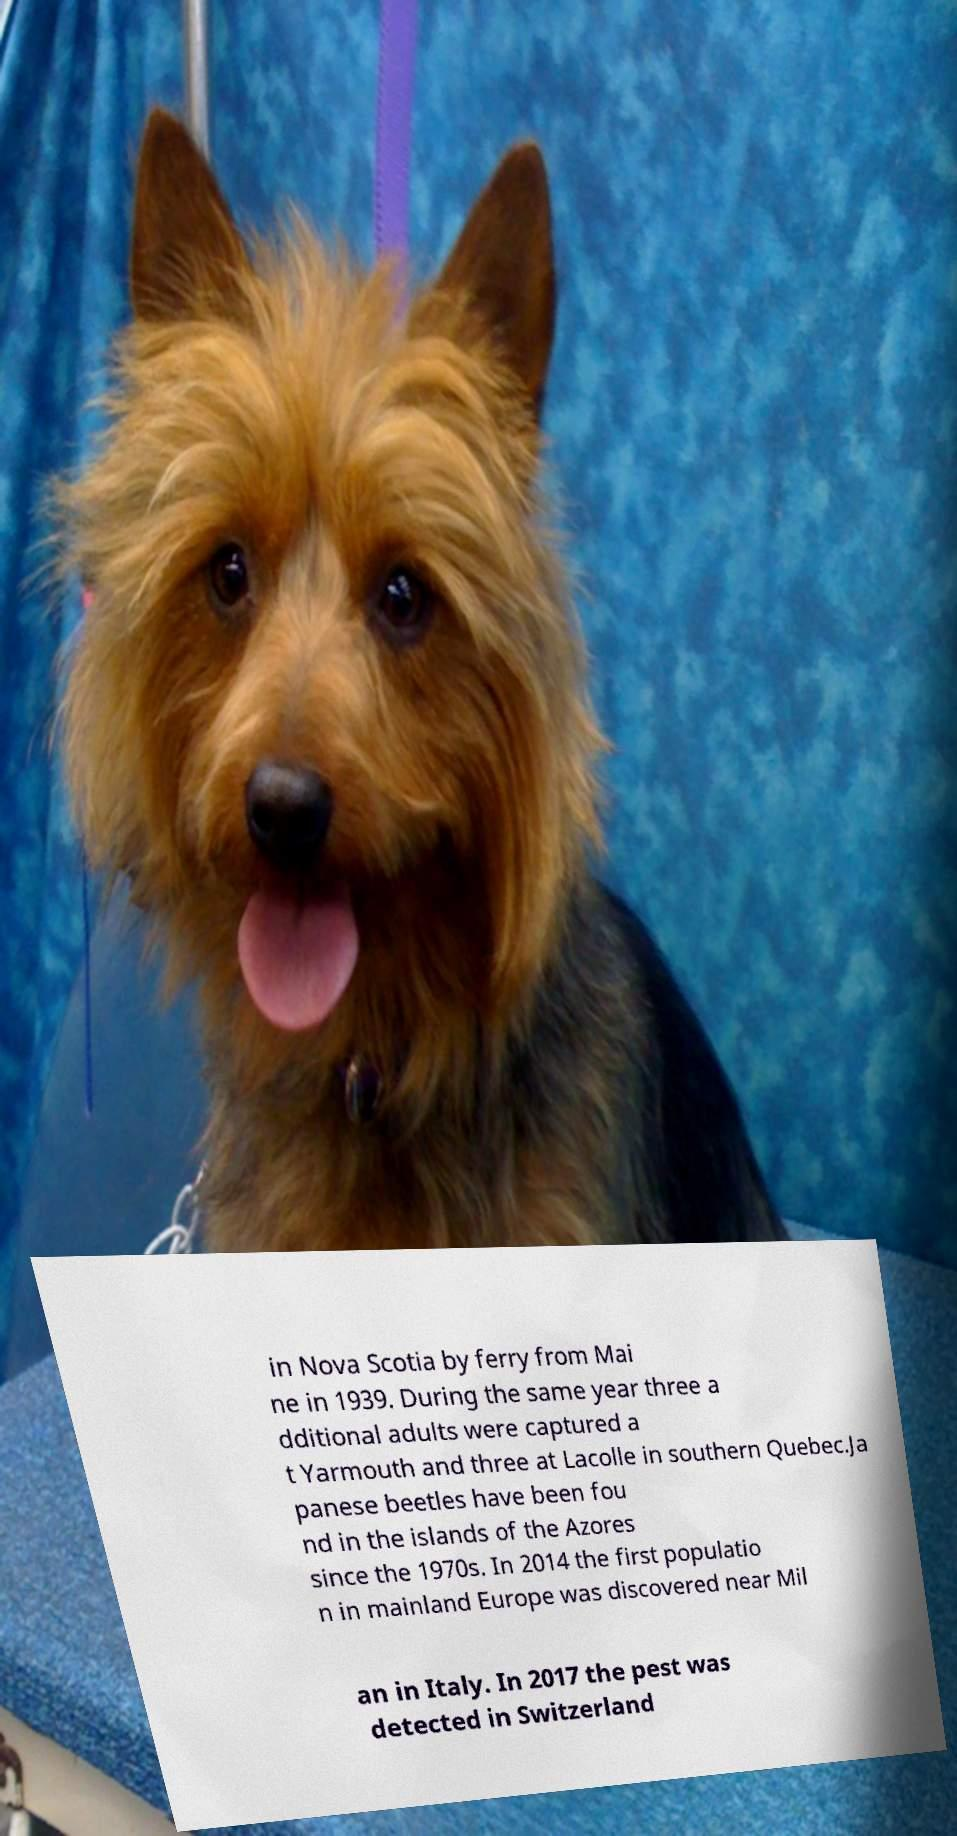Please identify and transcribe the text found in this image. in Nova Scotia by ferry from Mai ne in 1939. During the same year three a dditional adults were captured a t Yarmouth and three at Lacolle in southern Quebec.Ja panese beetles have been fou nd in the islands of the Azores since the 1970s. In 2014 the first populatio n in mainland Europe was discovered near Mil an in Italy. In 2017 the pest was detected in Switzerland 